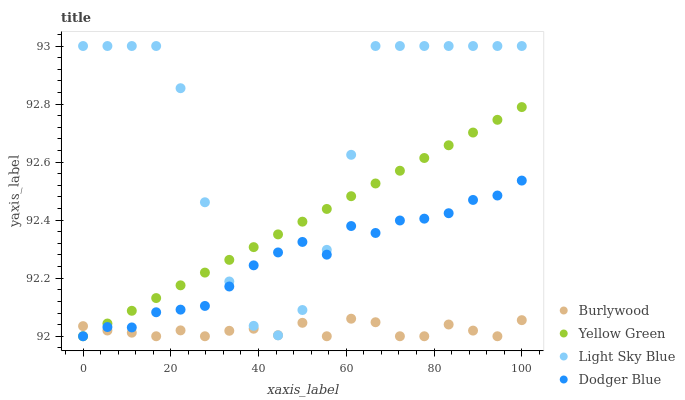Does Burlywood have the minimum area under the curve?
Answer yes or no. Yes. Does Light Sky Blue have the maximum area under the curve?
Answer yes or no. Yes. Does Dodger Blue have the minimum area under the curve?
Answer yes or no. No. Does Dodger Blue have the maximum area under the curve?
Answer yes or no. No. Is Yellow Green the smoothest?
Answer yes or no. Yes. Is Light Sky Blue the roughest?
Answer yes or no. Yes. Is Dodger Blue the smoothest?
Answer yes or no. No. Is Dodger Blue the roughest?
Answer yes or no. No. Does Burlywood have the lowest value?
Answer yes or no. Yes. Does Light Sky Blue have the lowest value?
Answer yes or no. No. Does Light Sky Blue have the highest value?
Answer yes or no. Yes. Does Dodger Blue have the highest value?
Answer yes or no. No. Does Dodger Blue intersect Yellow Green?
Answer yes or no. Yes. Is Dodger Blue less than Yellow Green?
Answer yes or no. No. Is Dodger Blue greater than Yellow Green?
Answer yes or no. No. 